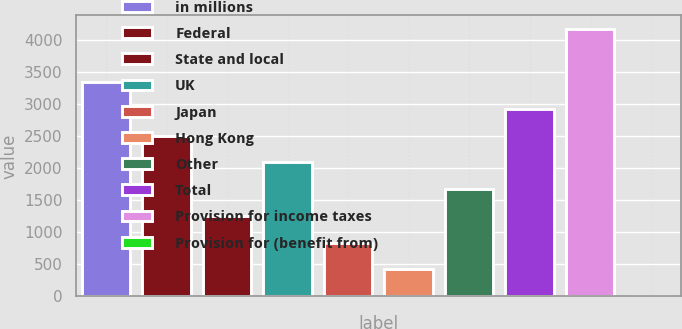Convert chart. <chart><loc_0><loc_0><loc_500><loc_500><bar_chart><fcel>in millions<fcel>Federal<fcel>State and local<fcel>UK<fcel>Japan<fcel>Hong Kong<fcel>Other<fcel>Total<fcel>Provision for income taxes<fcel>Provision for (benefit from)<nl><fcel>3335.8<fcel>2503.6<fcel>1255.3<fcel>2087.5<fcel>839.2<fcel>423.1<fcel>1671.4<fcel>2919.7<fcel>4168<fcel>7<nl></chart> 